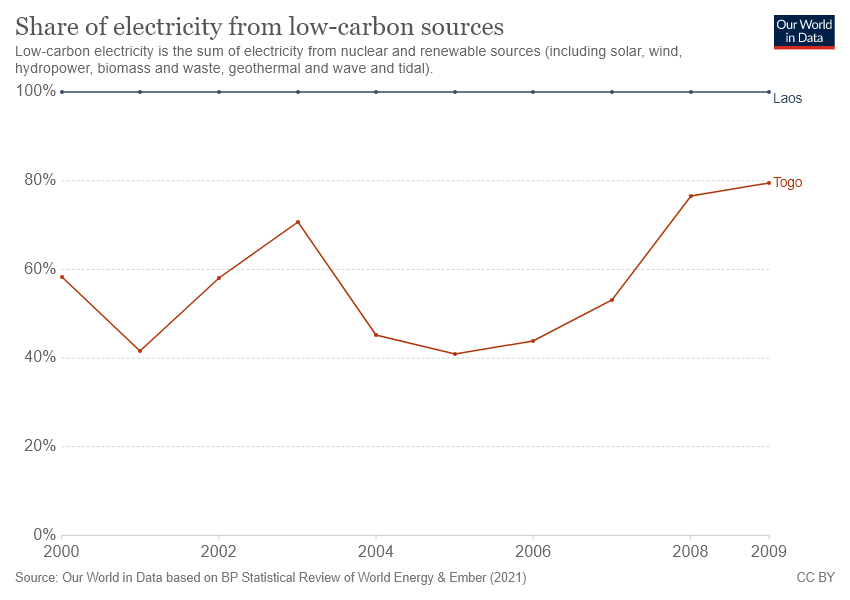Could you explain the significance of the fluctuation in Togo's low-carbon electricity share shown here? Certainly! The fluctuation in Togo's low-carbon electricity share, as depicted, could be due to various factors such as changes in energy policy, investment in renewable infrastructure, economic shifts, or even fluctuations in energy demand. The chart captures a significant dip and subsequent recovery, suggesting a period of transition or the impact of external events that temporarily affected the energy sector's composition. 